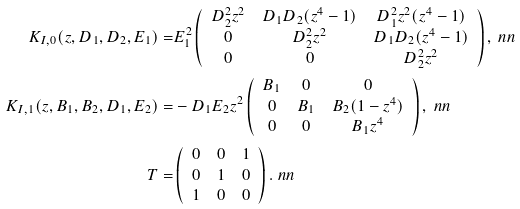<formula> <loc_0><loc_0><loc_500><loc_500>K _ { I , 0 } ( z , D _ { 1 } , D _ { 2 } , E _ { 1 } ) = & E _ { 1 } ^ { 2 } \left ( \begin{array} { c c c } D _ { 2 } ^ { 2 } z ^ { 2 } & D _ { 1 } D _ { 2 } ( z ^ { 4 } - 1 ) & D _ { 1 } ^ { 2 } z ^ { 2 } ( z ^ { 4 } - 1 ) \\ 0 & D _ { 2 } ^ { 2 } z ^ { 2 } & D _ { 1 } D _ { 2 } ( z ^ { 4 } - 1 ) \\ 0 & 0 & D _ { 2 } ^ { 2 } z ^ { 2 } \end{array} \right ) , \ n n \\ K _ { I , 1 } ( z , B _ { 1 } , B _ { 2 } , D _ { 1 } , E _ { 2 } ) = & - D _ { 1 } E _ { 2 } z ^ { 2 } \left ( \begin{array} { c c c } B _ { 1 } & 0 & 0 \\ 0 & B _ { 1 } & B _ { 2 } ( 1 - z ^ { 4 } ) \\ 0 & 0 & B _ { 1 } z ^ { 4 } \end{array} \right ) , \ n n \\ T = & \left ( \begin{array} { c c c } 0 & 0 & 1 \\ 0 & 1 & 0 \\ 1 & 0 & 0 \end{array} \right ) . \ n n</formula> 